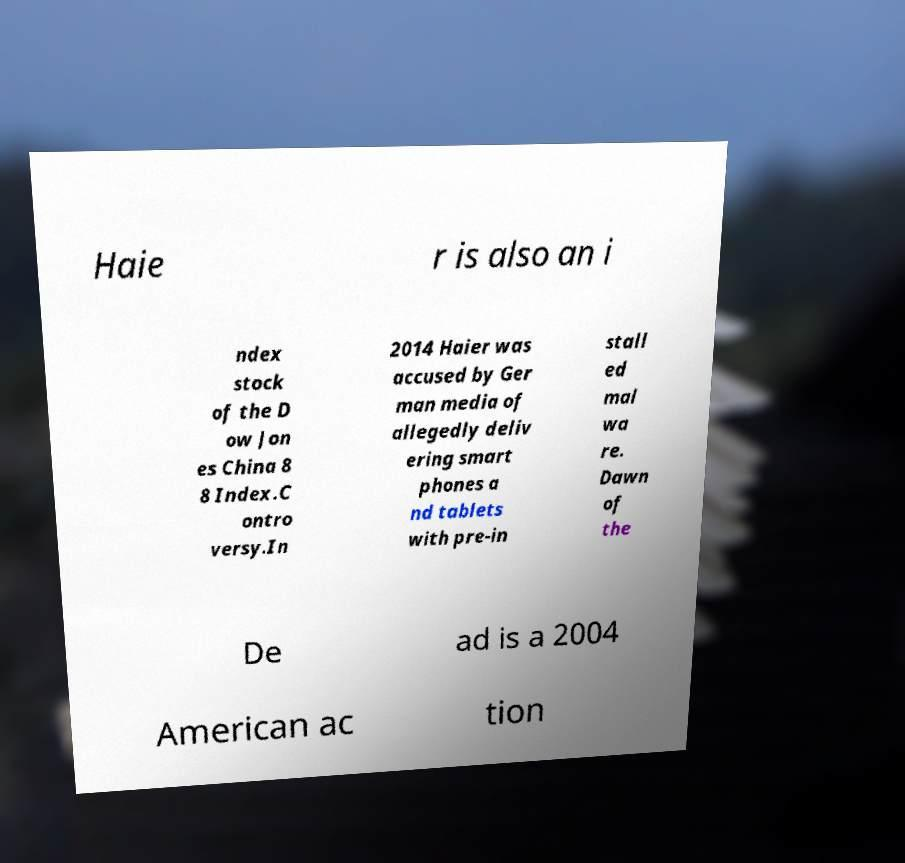Please read and relay the text visible in this image. What does it say? Haie r is also an i ndex stock of the D ow Jon es China 8 8 Index.C ontro versy.In 2014 Haier was accused by Ger man media of allegedly deliv ering smart phones a nd tablets with pre-in stall ed mal wa re. Dawn of the De ad is a 2004 American ac tion 